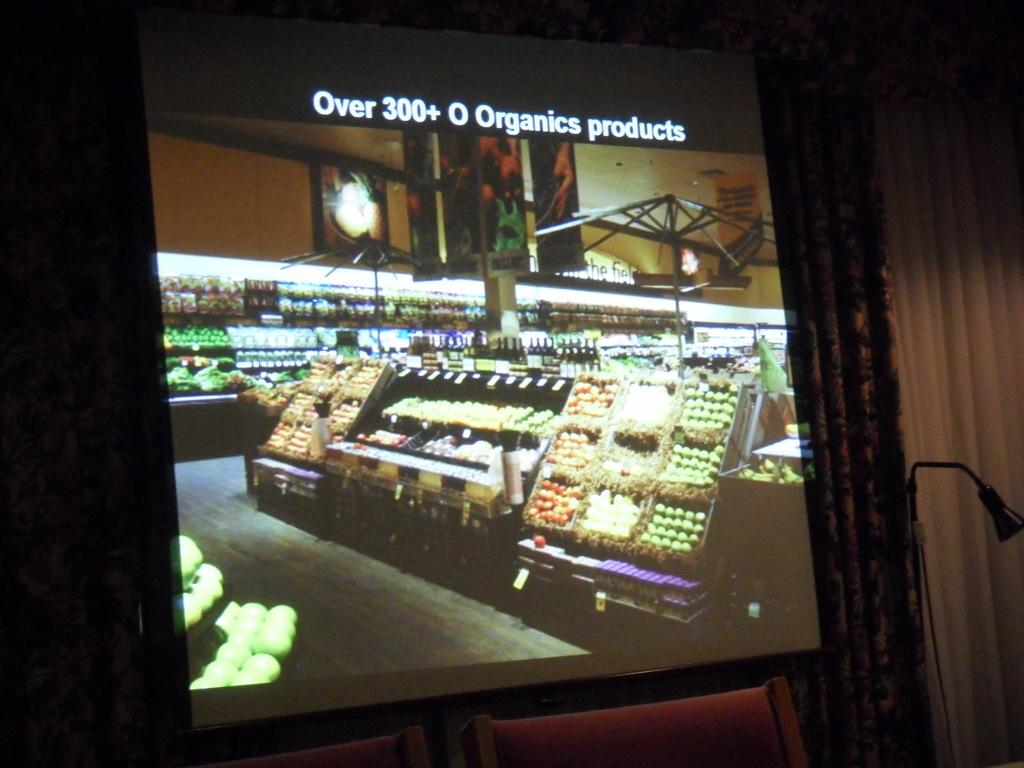<image>
Summarize the visual content of the image. A TV screen displays Over 300+ O Organics products. 